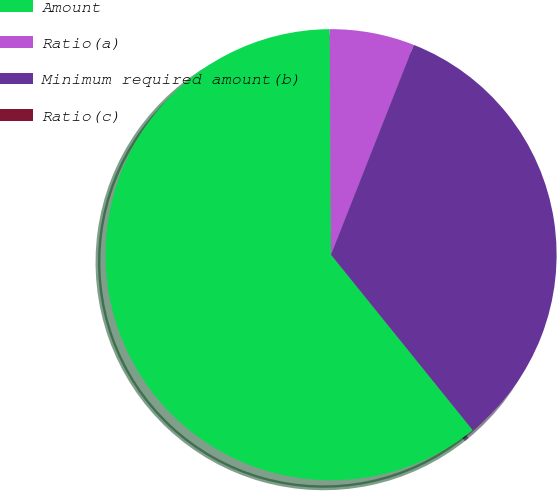<chart> <loc_0><loc_0><loc_500><loc_500><pie_chart><fcel>Amount<fcel>Ratio(a)<fcel>Minimum required amount(b)<fcel>Ratio(c)<nl><fcel>60.72%<fcel>6.07%<fcel>33.21%<fcel>0.0%<nl></chart> 